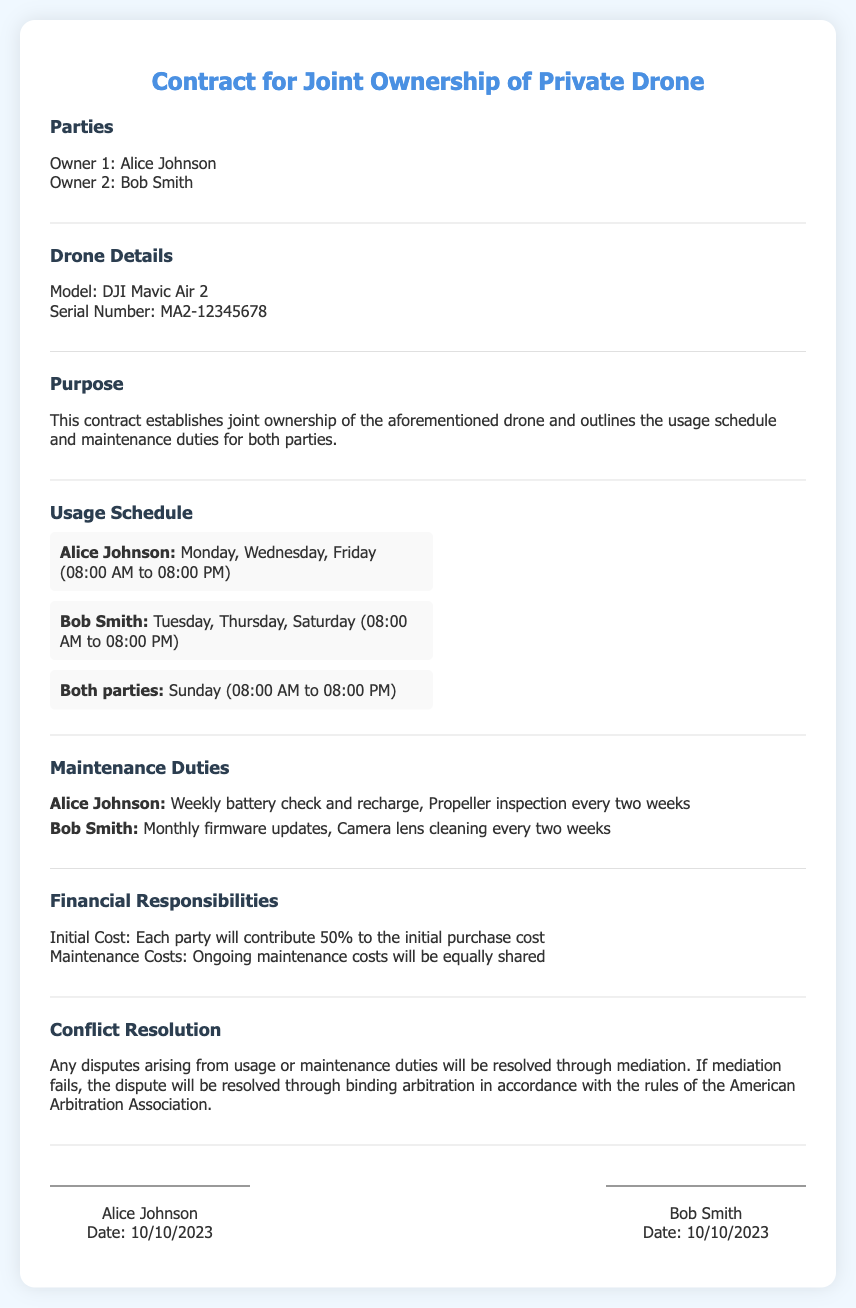What are the names of the owners? The names of the owners are mentioned in the document under the "Parties" section.
Answer: Alice Johnson, Bob Smith What is the drone model? The drone model is specified in the "Drone Details" section of the document.
Answer: DJI Mavic Air 2 What is the initial cost contribution ratio? The document states the ratio for initial cost contribution under "Financial Responsibilities".
Answer: 50% What are Alice's usage days? The usage schedule lists the days allocated for Alice Johnson.
Answer: Monday, Wednesday, Friday What maintenance duty is Bob responsible for? Bob's maintenance duties are listed in the "Maintenance Duties" section.
Answer: Monthly firmware updates On what day can both parties use the drone? The document specifies the day for joint usage of the drone in the "Usage Schedule" section.
Answer: Sunday What happens if mediation fails? The document indicates the procedure if mediation fails under "Conflict Resolution".
Answer: Binding arbitration What is the serial number of the drone? The serial number is provided in the "Drone Details" section of the document.
Answer: MA2-12345678 How often does Alice check the battery? The frequency of Alice's battery check is outlined in the "Maintenance Duties".
Answer: Weekly 